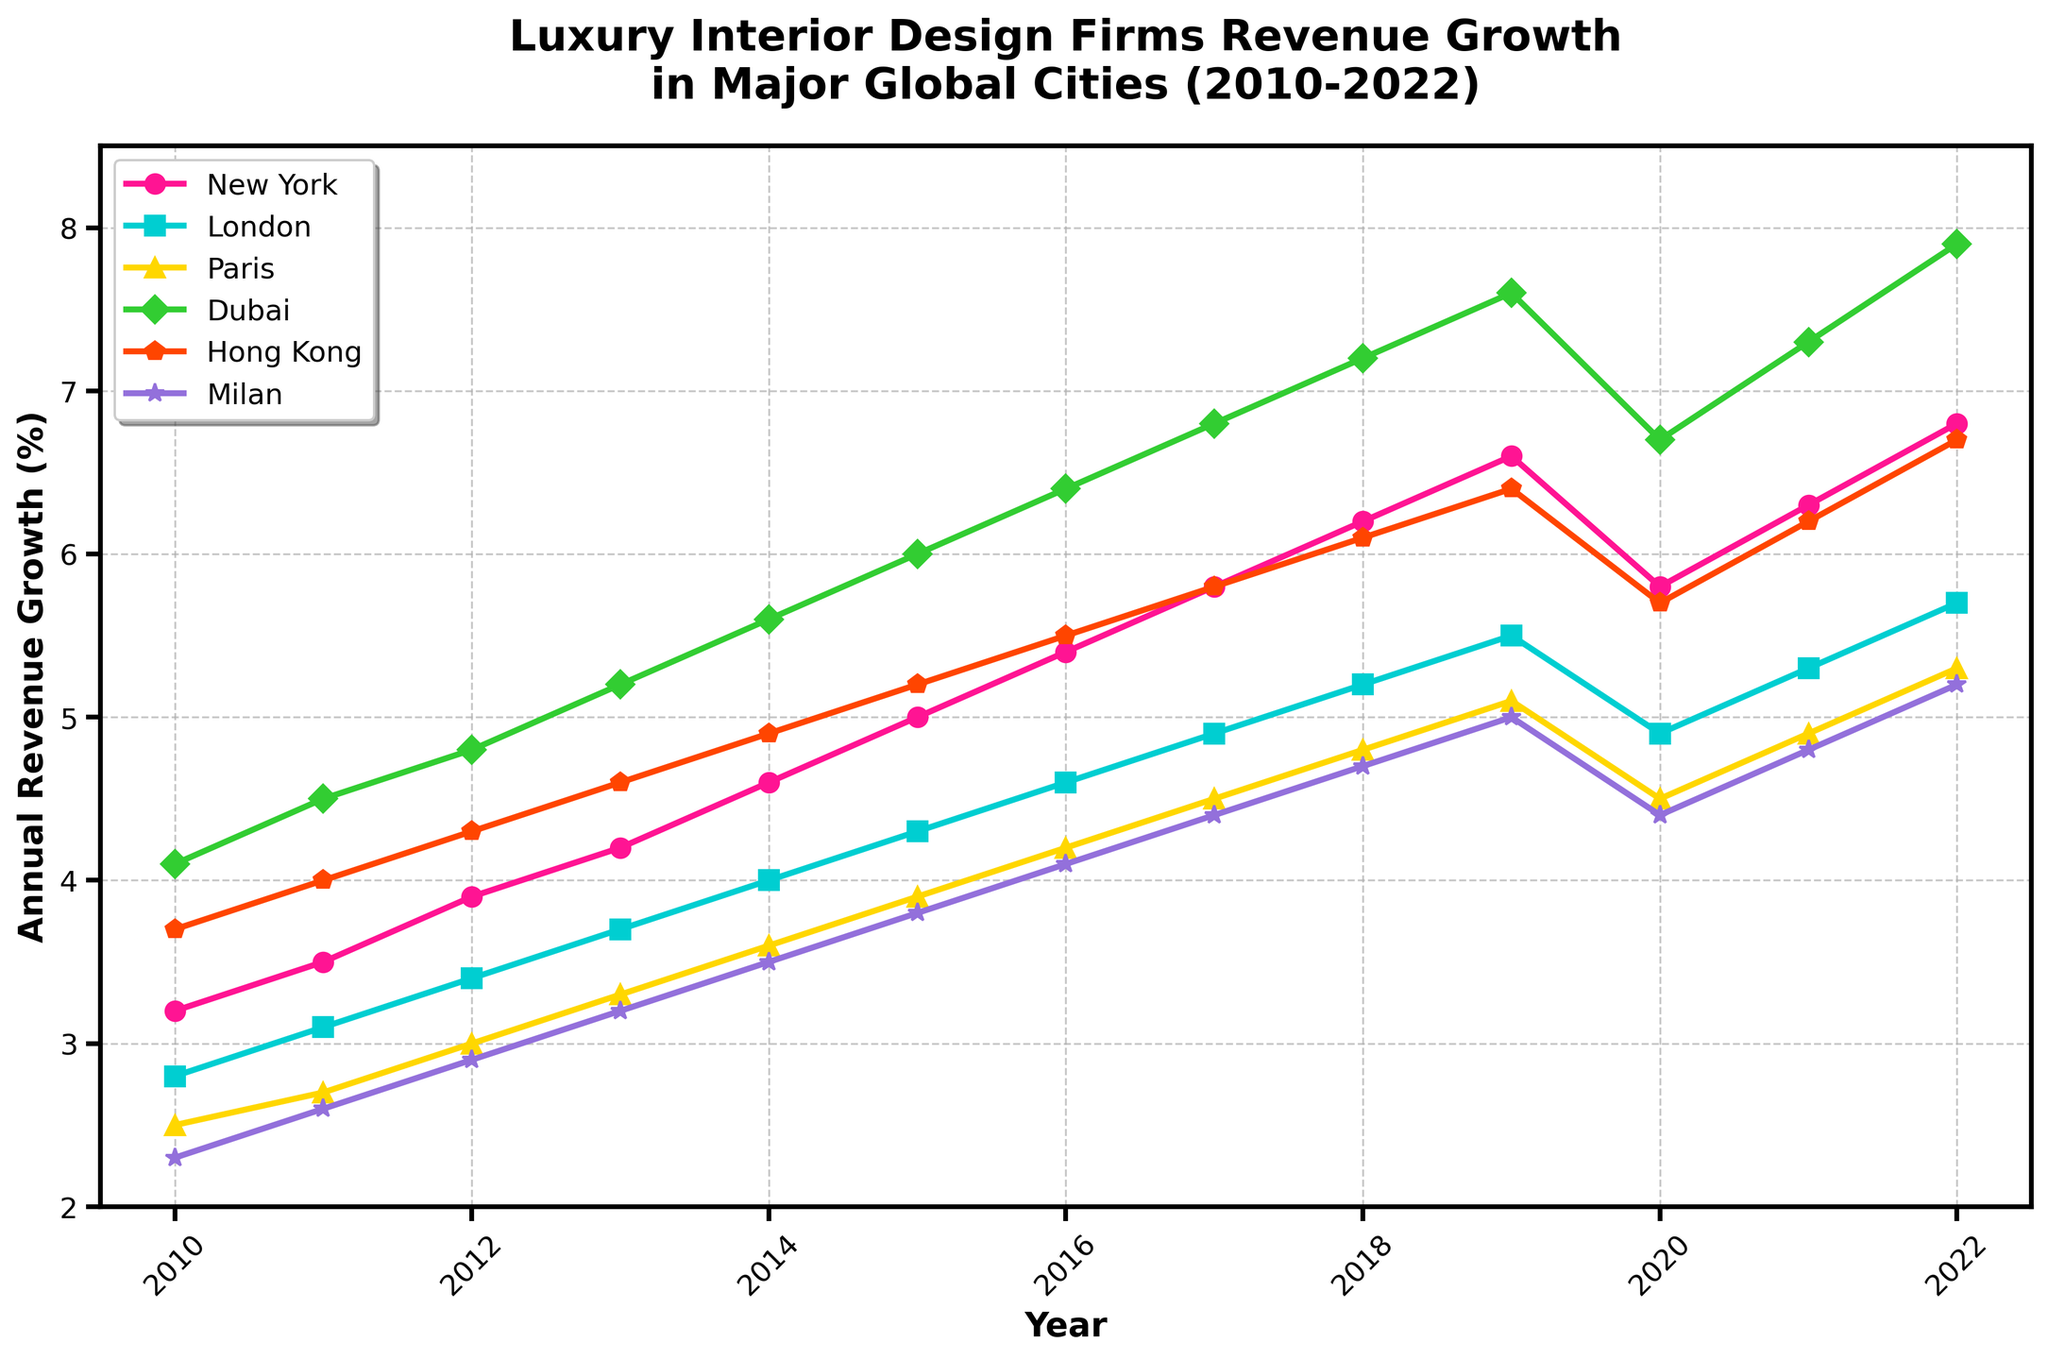What's the trend of annual revenue growth for New York from 2010 to 2022? The growth starts from 3.2% in 2010 and rises steadily each year until reaching 6.8% in 2022, with a slight dip in 2020 to 5.8%.
Answer: Steady increase with a dip in 2020 Which city had the highest annual revenue growth in 2022, and what was the percentage? Looking at the 2022 data points, Dubai shows the highest growth at 7.9%.
Answer: Dubai at 7.9% Between 2015 and 2016, which city experienced the largest increase in revenue growth percentage? Calculate the yearly changes: New York (5.4-5.0=0.4), London (4.6-4.3=0.3), Paris (4.2-3.9=0.3), Dubai (6.4-6.0=0.4), Hong Kong (5.5-5.2=0.3), Milan (4.1-3.8=0.3). Both New York and Dubai show the largest increase of 0.4%.
Answer: New York and Dubai, 0.4% How did the annual revenue growth for Milan compare to the other cities in 2010? Milan had the lowest growth at 2.3% compared to New York (3.2%), London (2.8%), Paris (2.5%), Dubai (4.1%), and Hong Kong (3.7%).
Answer: Lowest at 2.3% What is the difference in annual revenue growth between Dubai and Hong Kong in 2022? Dubai's growth is 7.9% and Hong Kong's is 6.7% in 2022, the difference is 7.9 - 6.7 = 1.2%.
Answer: 1.2% In which year did New York surpass 5% annual revenue growth for the first time? By scanning the New York data, it first surpasses 5% in 2015.
Answer: 2015 Calculate the average annual revenue growth for Paris over the 13 years. Sum all Paris percentages (2.5 + 2.7 + 3.0 + 3.3 + 3.6 + 3.9 + 4.2 + 4.5 + 4.8 + 5.1 + 4.5 + 4.9 + 5.3 = 52.3). Average is 52.3/13 = 4.02%.
Answer: 4.02% What visual element is used to represent the revenue growth for Hong Kong? Hong Kong's growth is represented by an orange line with triangle markers.
Answer: Orange line with triangle markers 